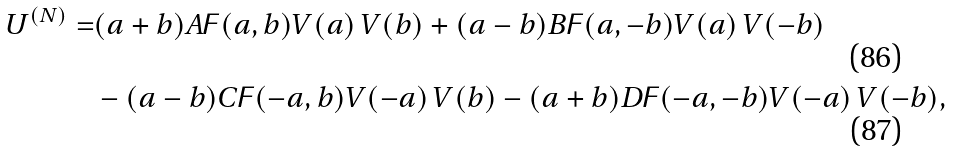<formula> <loc_0><loc_0><loc_500><loc_500>U ^ { ( N ) } = & ( a + b ) A \digamma ( a , b ) V ( a ) \, V ( b ) + ( a - b ) B \digamma ( a , - b ) V ( a ) \, V ( - b ) \\ & - ( a - b ) C \digamma ( - a , b ) V ( - a ) \, V ( b ) - ( a + b ) D \digamma ( - a , - b ) V ( - a ) \, V ( - b ) ,</formula> 